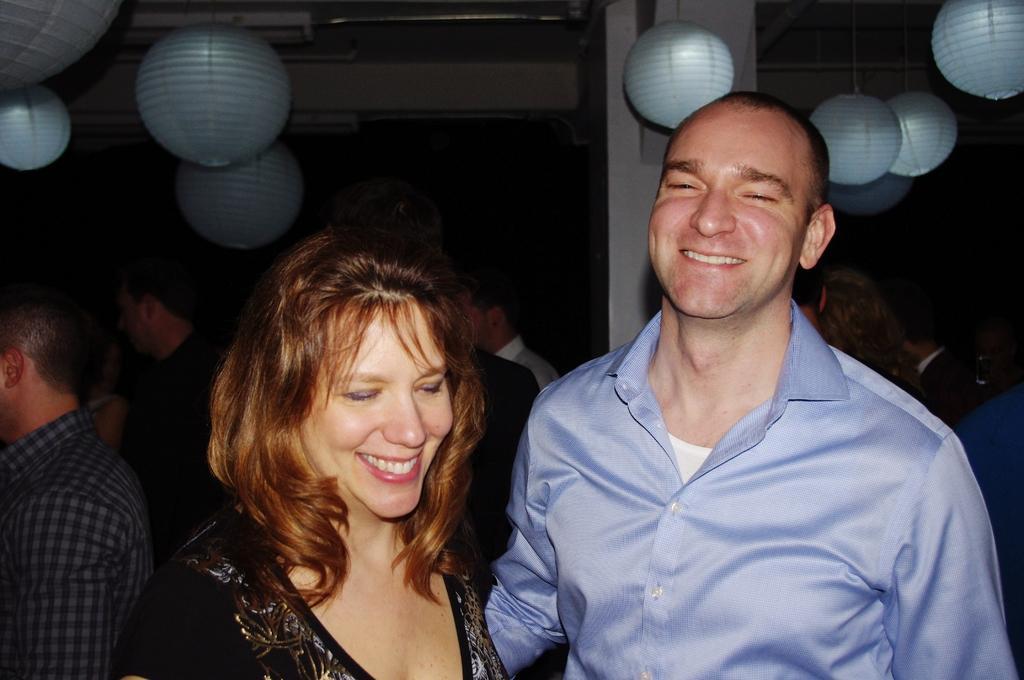Describe this image in one or two sentences. In front of the image there is a man and a woman with a smile on their face, behind them there are a few people standing, at the top of the image there are lamps hanging from the ceiling and there is a pillar. 